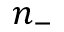Convert formula to latex. <formula><loc_0><loc_0><loc_500><loc_500>n _ { - }</formula> 